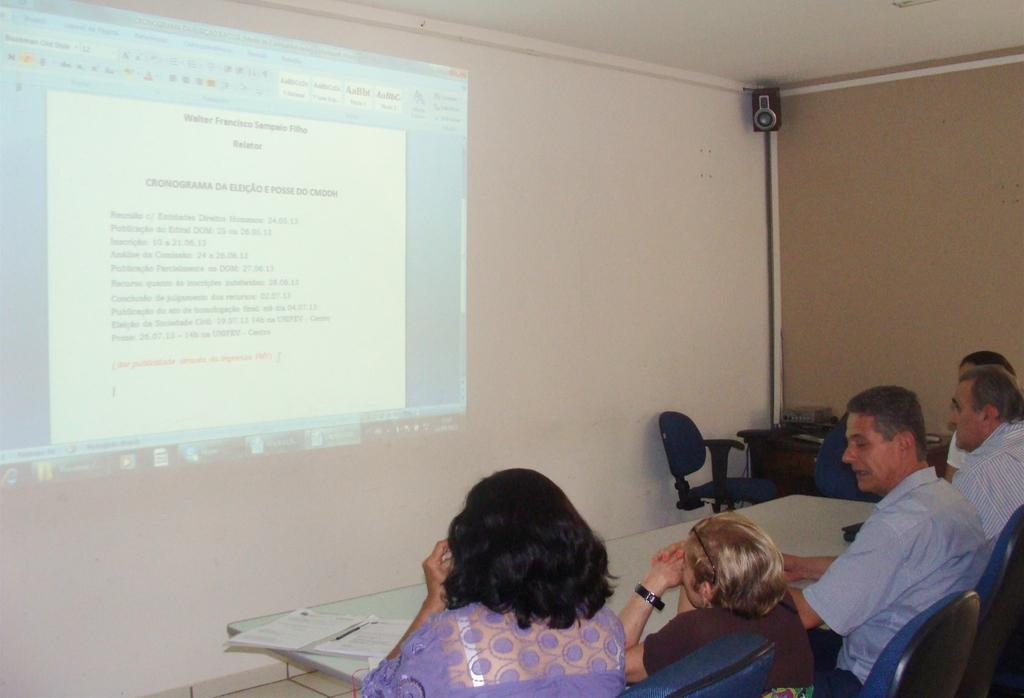How many people are in the image? There is a group of people in the image. What are the people doing in the image? The people are sitting in chairs. What is in front of the people? There is a table in front of the people. What is on the wall in the image? There is a projected image on the wall. Where is the speaker located in the image? The speaker is in the right corner of the image. How many fangs can be seen on the rabbits in the image? There are no rabbits or fangs present in the image. What type of ants are crawling on the table in the image? There are no ants present in the image. 